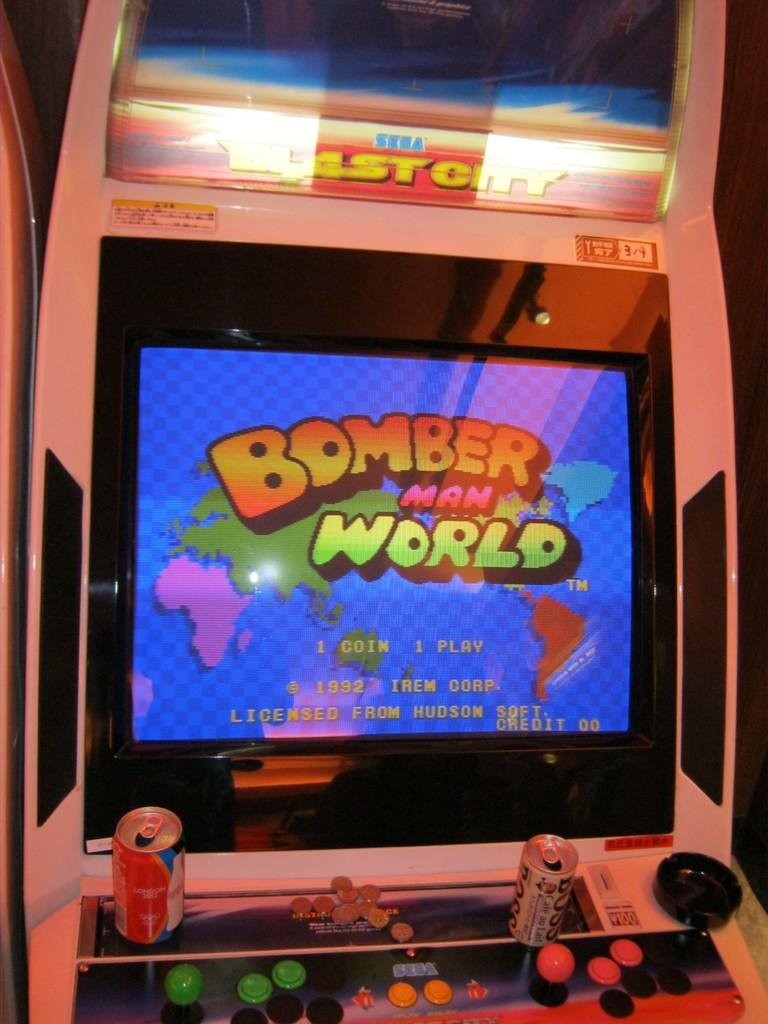What is the main object in the image? There is a screen in the image. What can be seen on the screen? Something is written on the screen. What objects are in front of the screen? There are two tins in front of the screen. What other items are visible in the image? There are multi-colored balls in the image. How does the quicksand affect the screen in the image? There is no quicksand present in the image, so it does not affect the screen. 